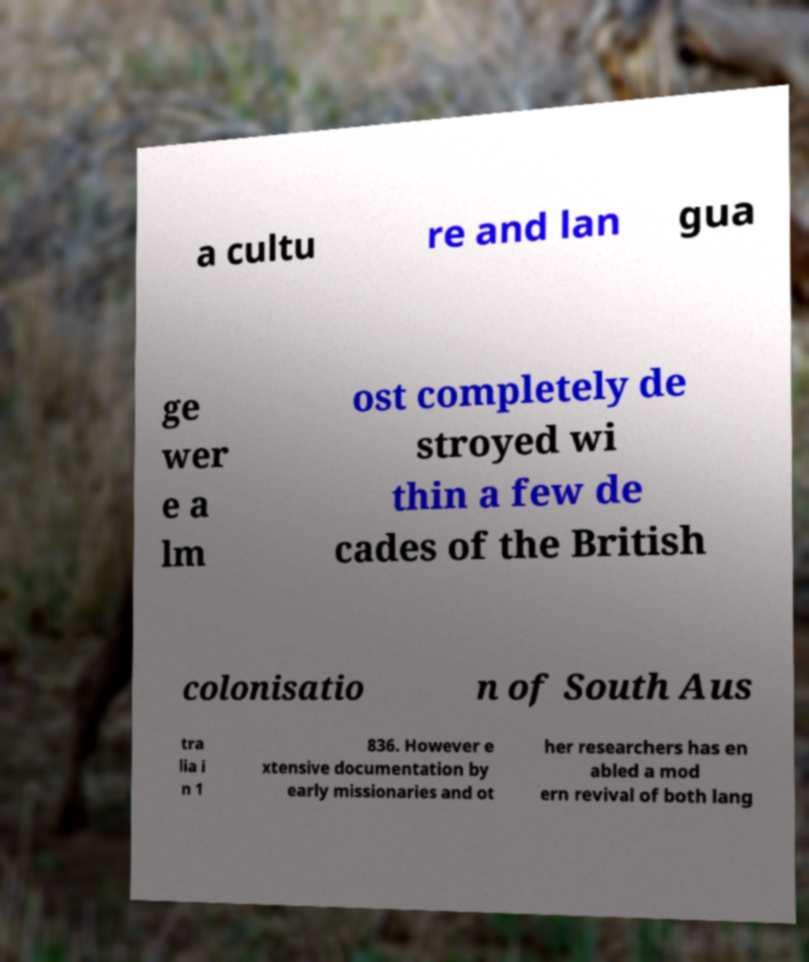Could you assist in decoding the text presented in this image and type it out clearly? a cultu re and lan gua ge wer e a lm ost completely de stroyed wi thin a few de cades of the British colonisatio n of South Aus tra lia i n 1 836. However e xtensive documentation by early missionaries and ot her researchers has en abled a mod ern revival of both lang 